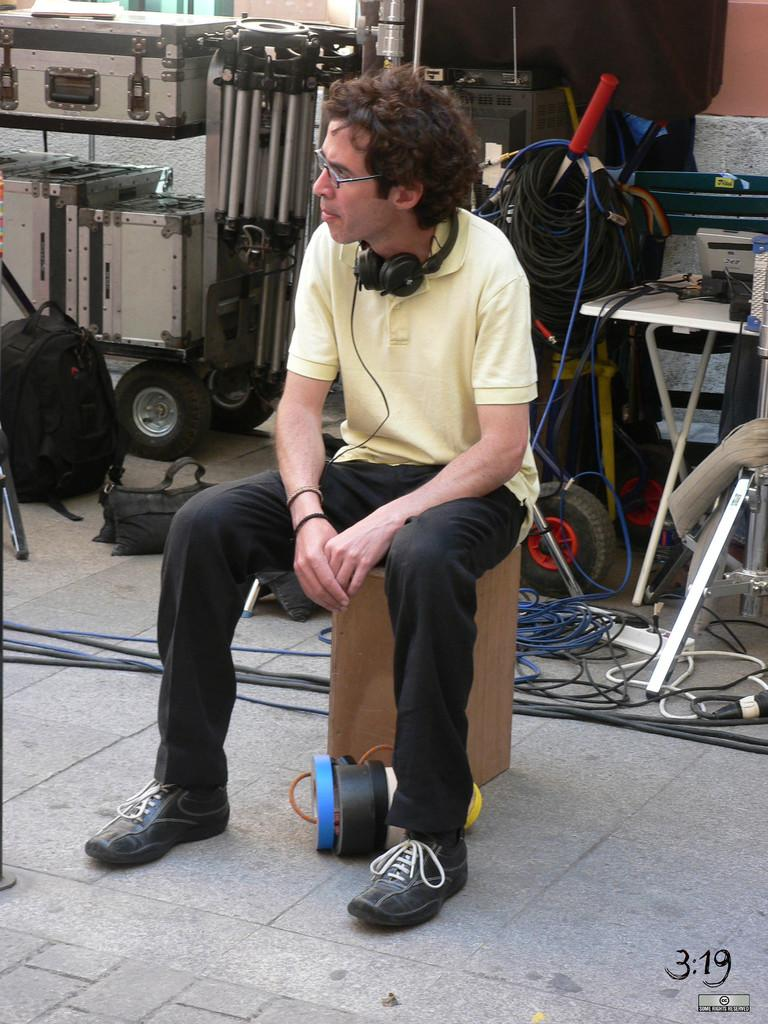What is the main subject of the image? The main subject of the image is a man sitting in the center. What is the man sitting on? The man is sitting on a wooden stool. What objects can be seen in the background of the image? There is a box, a table, wires, and a black color bag visible in the background. Are there any giants playing with the man in the image? There are no giants present in the image, and the man is not playing with anyone. 